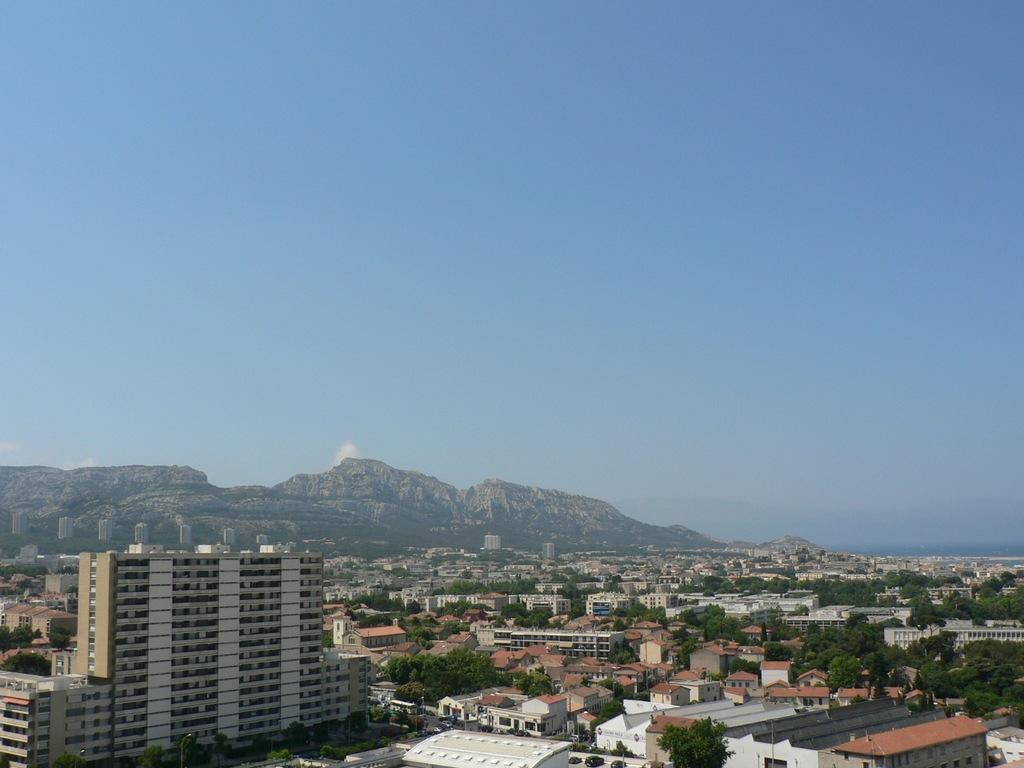What type of natural elements can be seen in the image? There are trees in the image. What type of man-made structures are present in the image? There are buildings in the image. What can be seen in the distance in the image? There are hills in the background of the image. What is visible at the top of the image? The sky is visible at the top of the image. What type of weather can be seen in the image? The provided facts do not mention any specific weather conditions, so it cannot be determined from the image. Can you tell me how many babies are present in the image? There are no babies present in the image. 